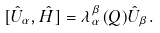Convert formula to latex. <formula><loc_0><loc_0><loc_500><loc_500>[ \hat { U } _ { \alpha } , \hat { H } ] = \lambda _ { \alpha } ^ { \beta } ( Q ) \hat { U } _ { \beta } .</formula> 